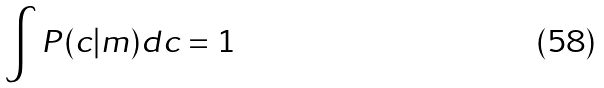<formula> <loc_0><loc_0><loc_500><loc_500>\int P ( c | m ) d c = 1</formula> 